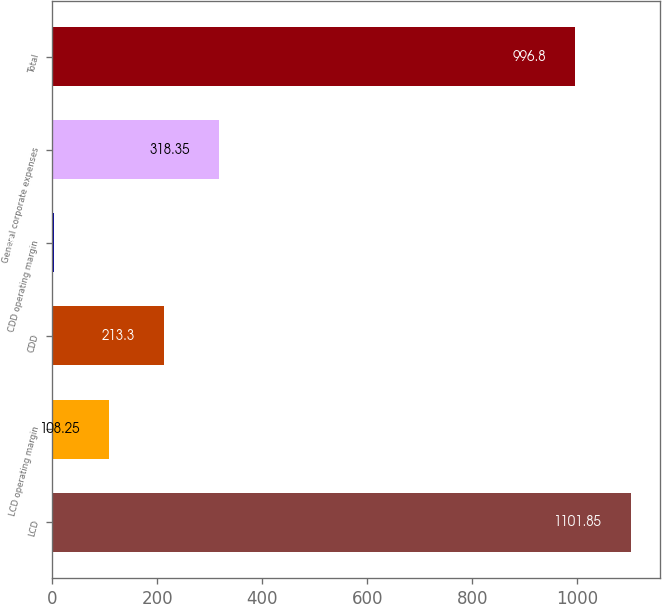Convert chart. <chart><loc_0><loc_0><loc_500><loc_500><bar_chart><fcel>LCD<fcel>LCD operating margin<fcel>CDD<fcel>CDD operating margin<fcel>General corporate expenses<fcel>Total<nl><fcel>1101.85<fcel>108.25<fcel>213.3<fcel>3.2<fcel>318.35<fcel>996.8<nl></chart> 